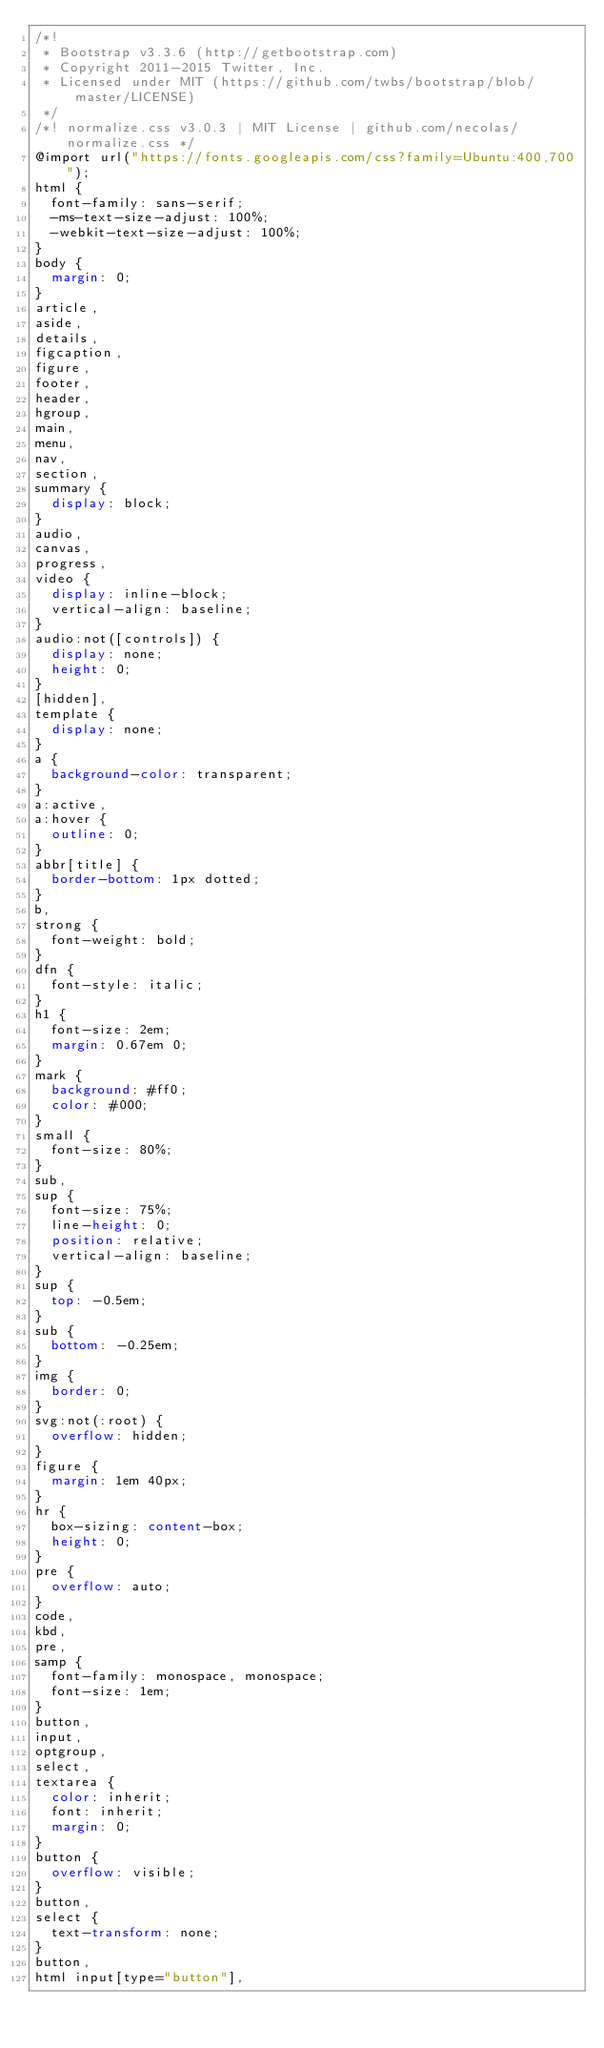<code> <loc_0><loc_0><loc_500><loc_500><_CSS_>/*!
 * Bootstrap v3.3.6 (http://getbootstrap.com)
 * Copyright 2011-2015 Twitter, Inc.
 * Licensed under MIT (https://github.com/twbs/bootstrap/blob/master/LICENSE)
 */
/*! normalize.css v3.0.3 | MIT License | github.com/necolas/normalize.css */
@import url("https://fonts.googleapis.com/css?family=Ubuntu:400,700");
html {
  font-family: sans-serif;
  -ms-text-size-adjust: 100%;
  -webkit-text-size-adjust: 100%;
}
body {
  margin: 0;
}
article,
aside,
details,
figcaption,
figure,
footer,
header,
hgroup,
main,
menu,
nav,
section,
summary {
  display: block;
}
audio,
canvas,
progress,
video {
  display: inline-block;
  vertical-align: baseline;
}
audio:not([controls]) {
  display: none;
  height: 0;
}
[hidden],
template {
  display: none;
}
a {
  background-color: transparent;
}
a:active,
a:hover {
  outline: 0;
}
abbr[title] {
  border-bottom: 1px dotted;
}
b,
strong {
  font-weight: bold;
}
dfn {
  font-style: italic;
}
h1 {
  font-size: 2em;
  margin: 0.67em 0;
}
mark {
  background: #ff0;
  color: #000;
}
small {
  font-size: 80%;
}
sub,
sup {
  font-size: 75%;
  line-height: 0;
  position: relative;
  vertical-align: baseline;
}
sup {
  top: -0.5em;
}
sub {
  bottom: -0.25em;
}
img {
  border: 0;
}
svg:not(:root) {
  overflow: hidden;
}
figure {
  margin: 1em 40px;
}
hr {
  box-sizing: content-box;
  height: 0;
}
pre {
  overflow: auto;
}
code,
kbd,
pre,
samp {
  font-family: monospace, monospace;
  font-size: 1em;
}
button,
input,
optgroup,
select,
textarea {
  color: inherit;
  font: inherit;
  margin: 0;
}
button {
  overflow: visible;
}
button,
select {
  text-transform: none;
}
button,
html input[type="button"],</code> 